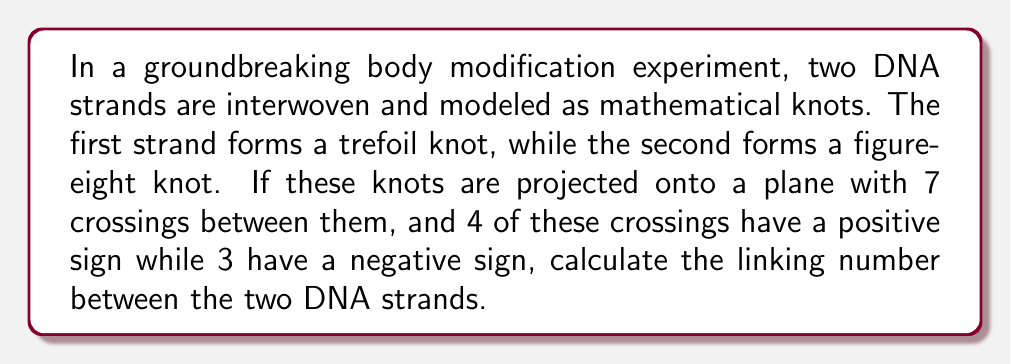Solve this math problem. To solve this problem, we'll follow these steps:

1. Understand the concept of linking number:
   The linking number is a topological invariant that describes how two closed curves are linked in three-dimensional space. It can be calculated from a projection of the link onto a plane.

2. Recall the formula for linking number:
   $$Lk = \frac{1}{2}\sum_{i} \epsilon_i$$
   where $\epsilon_i$ is the sign of each crossing between the two components (+1 for positive crossings, -1 for negative crossings).

3. Identify the relevant information:
   - Total number of crossings between the two knots: 7
   - Number of positive crossings: 4
   - Number of negative crossings: 3

4. Calculate the sum of crossing signs:
   $$\sum_{i} \epsilon_i = (+1 \times 4) + (-1 \times 3) = 4 - 3 = 1$$

5. Apply the linking number formula:
   $$Lk = \frac{1}{2} \times 1 = \frac{1}{2}$$

Therefore, the linking number between the two DNA strands modeled as knots is 1/2.
Answer: $\frac{1}{2}$ 